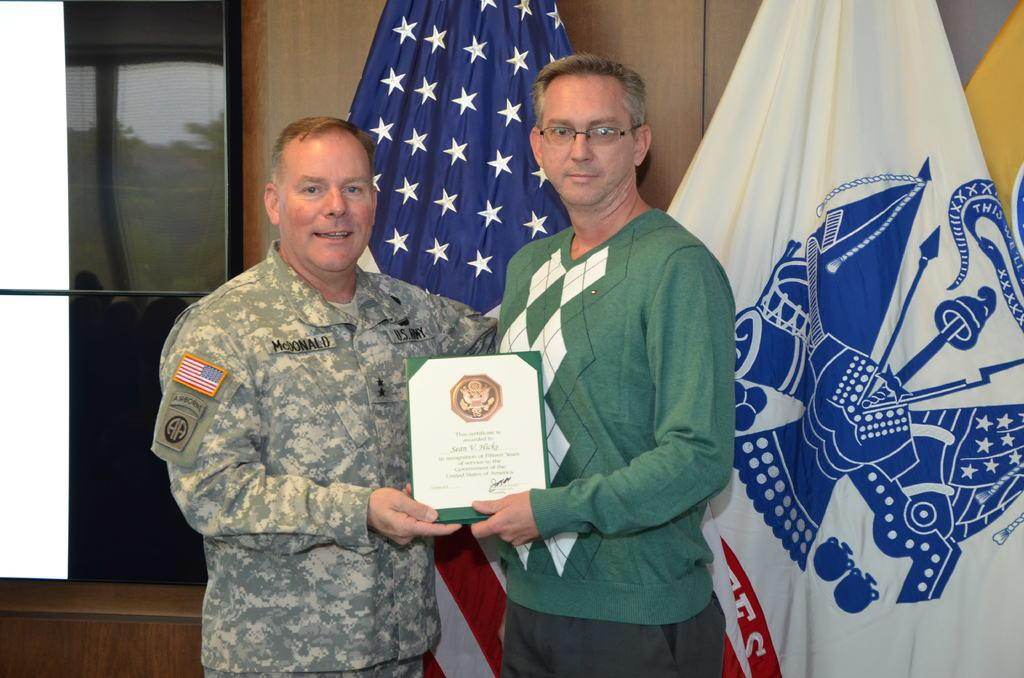How many people are in the image? There are two persons in the image. What are the persons doing in the image? The persons are holding a frame with one hand. Where are the persons standing in the image? The persons are standing on a floor. What can be seen in the background of the image? There are two flags in the background of the image. Where are the flags located in relation to the wall? The flags are near a wall. What type of creature is offering a fly to the persons in the image? There is no creature present in the image, nor is there any mention of a fly or an offering. 